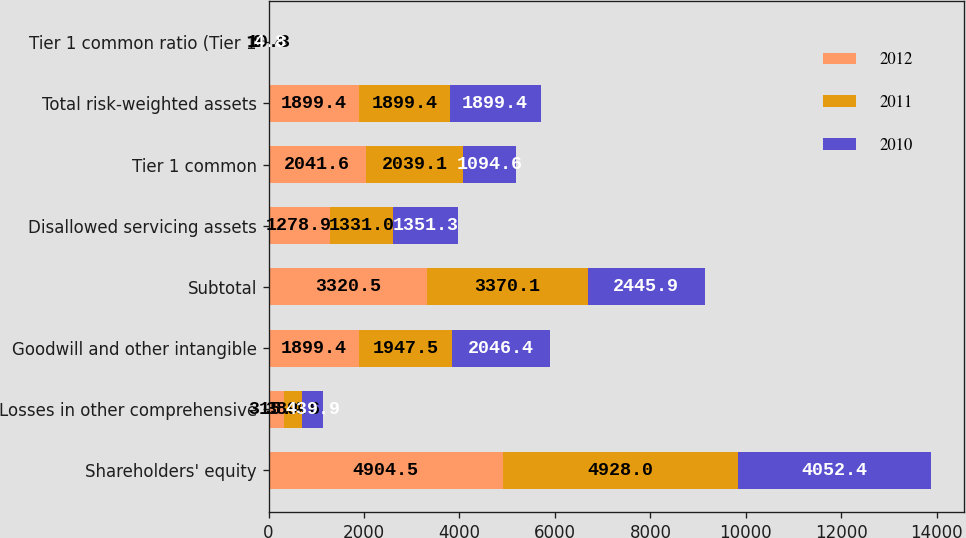Convert chart. <chart><loc_0><loc_0><loc_500><loc_500><stacked_bar_chart><ecel><fcel>Shareholders' equity<fcel>Losses in other comprehensive<fcel>Goodwill and other intangible<fcel>Subtotal<fcel>Disallowed servicing assets<fcel>Tier 1 common<fcel>Total risk-weighted assets<fcel>Tier 1 common ratio (Tier 1<nl><fcel>2012<fcel>4904.5<fcel>315.4<fcel>1899.4<fcel>3320.5<fcel>1278.9<fcel>2041.6<fcel>1899.4<fcel>10.3<nl><fcel>2011<fcel>4928<fcel>389.6<fcel>1947.5<fcel>3370.1<fcel>1331<fcel>2039.1<fcel>1899.4<fcel>9.4<nl><fcel>2010<fcel>4052.4<fcel>439.9<fcel>2046.4<fcel>2445.9<fcel>1351.3<fcel>1094.6<fcel>1899.4<fcel>4.8<nl></chart> 